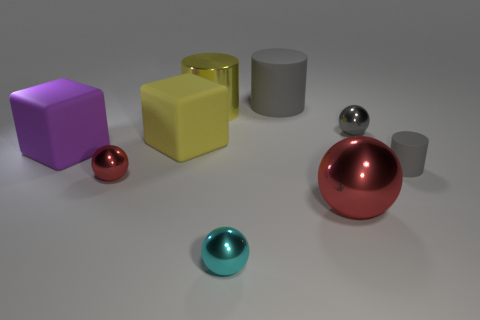How many gray cylinders must be subtracted to get 1 gray cylinders? 1 Subtract all matte cylinders. How many cylinders are left? 1 Add 1 small rubber cylinders. How many objects exist? 10 Subtract all yellow cylinders. How many cylinders are left? 2 Subtract 1 cyan balls. How many objects are left? 8 Subtract all spheres. How many objects are left? 5 Subtract 1 cubes. How many cubes are left? 1 Subtract all blue balls. Subtract all green cubes. How many balls are left? 4 Subtract all purple cylinders. How many yellow cubes are left? 1 Subtract all purple metallic things. Subtract all big cubes. How many objects are left? 7 